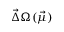<formula> <loc_0><loc_0><loc_500><loc_500>\vec { \Delta } \Omega ( \vec { \mu } )</formula> 